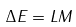Convert formula to latex. <formula><loc_0><loc_0><loc_500><loc_500>\Delta E = L M</formula> 